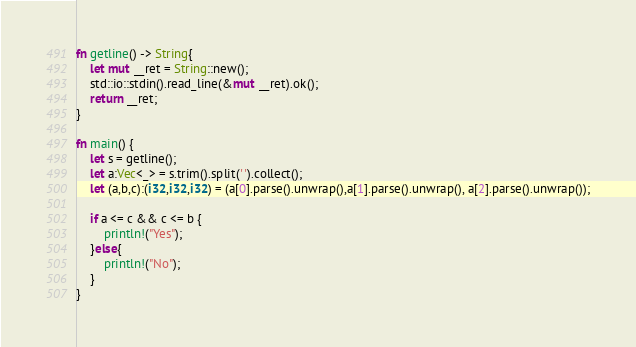<code> <loc_0><loc_0><loc_500><loc_500><_Rust_>fn getline() -> String{
    let mut __ret = String::new();
    std::io::stdin().read_line(&mut __ret).ok();
    return __ret;
}

fn main() {
    let s = getline();
    let a:Vec<_> = s.trim().split(' ').collect();
    let (a,b,c):(i32,i32,i32) = (a[0].parse().unwrap(),a[1].parse().unwrap(), a[2].parse().unwrap());

    if a <= c && c <= b {
        println!("Yes");
    }else{ 
        println!("No");
    }
}
</code> 